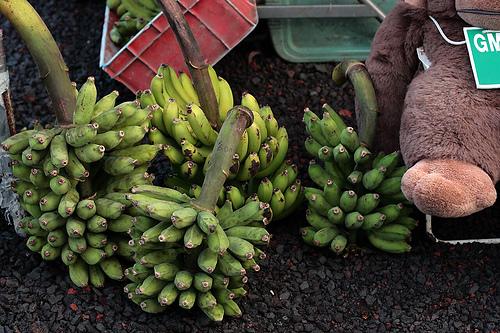What kind of fruit is this?
Be succinct. Bananas. Is there a stuffed animal in the photo?
Keep it brief. Yes. Are these bananas for sale in a US supermarket?
Be succinct. No. 